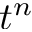<formula> <loc_0><loc_0><loc_500><loc_500>t ^ { n }</formula> 